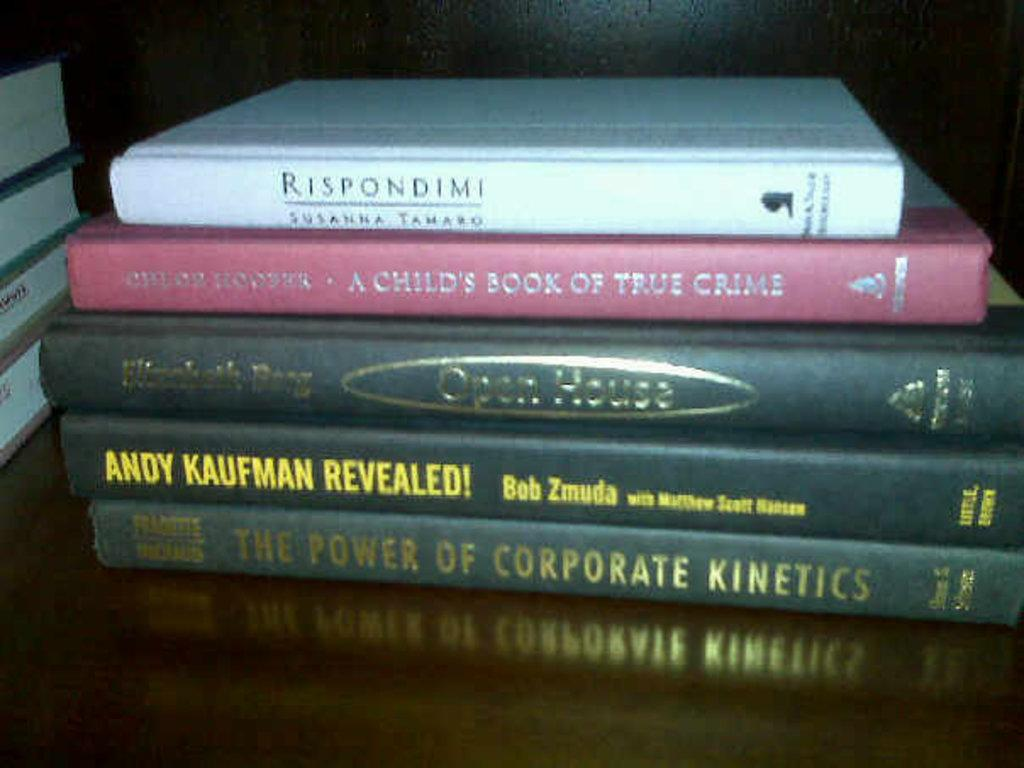<image>
Render a clear and concise summary of the photo. A group of books, with at least one being about corporate topics and at least one other about true crime. 